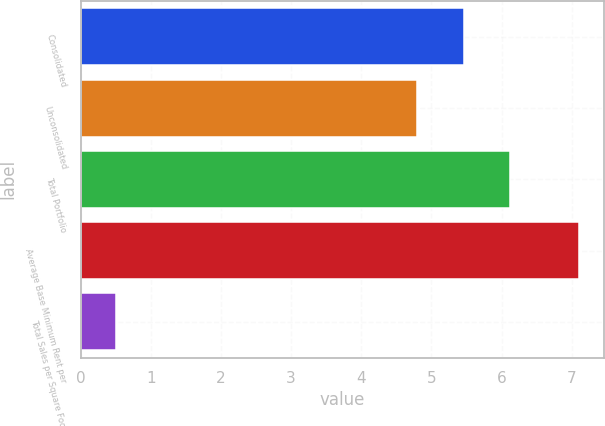Convert chart to OTSL. <chart><loc_0><loc_0><loc_500><loc_500><bar_chart><fcel>Consolidated<fcel>Unconsolidated<fcel>Total Portfolio<fcel>Average Base Minimum Rent per<fcel>Total Sales per Square Foot<nl><fcel>5.46<fcel>4.8<fcel>6.12<fcel>7.1<fcel>0.5<nl></chart> 